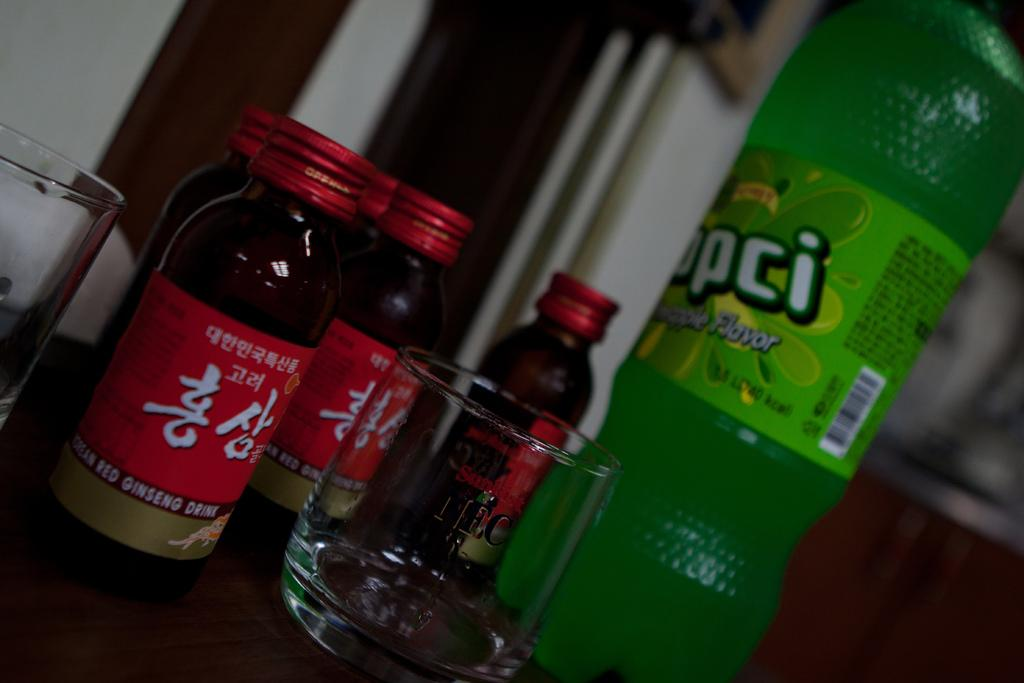<image>
Offer a succinct explanation of the picture presented. The red bottles with Korean characters have labels that say "ginseng drink" near the bottom of the bottle. 